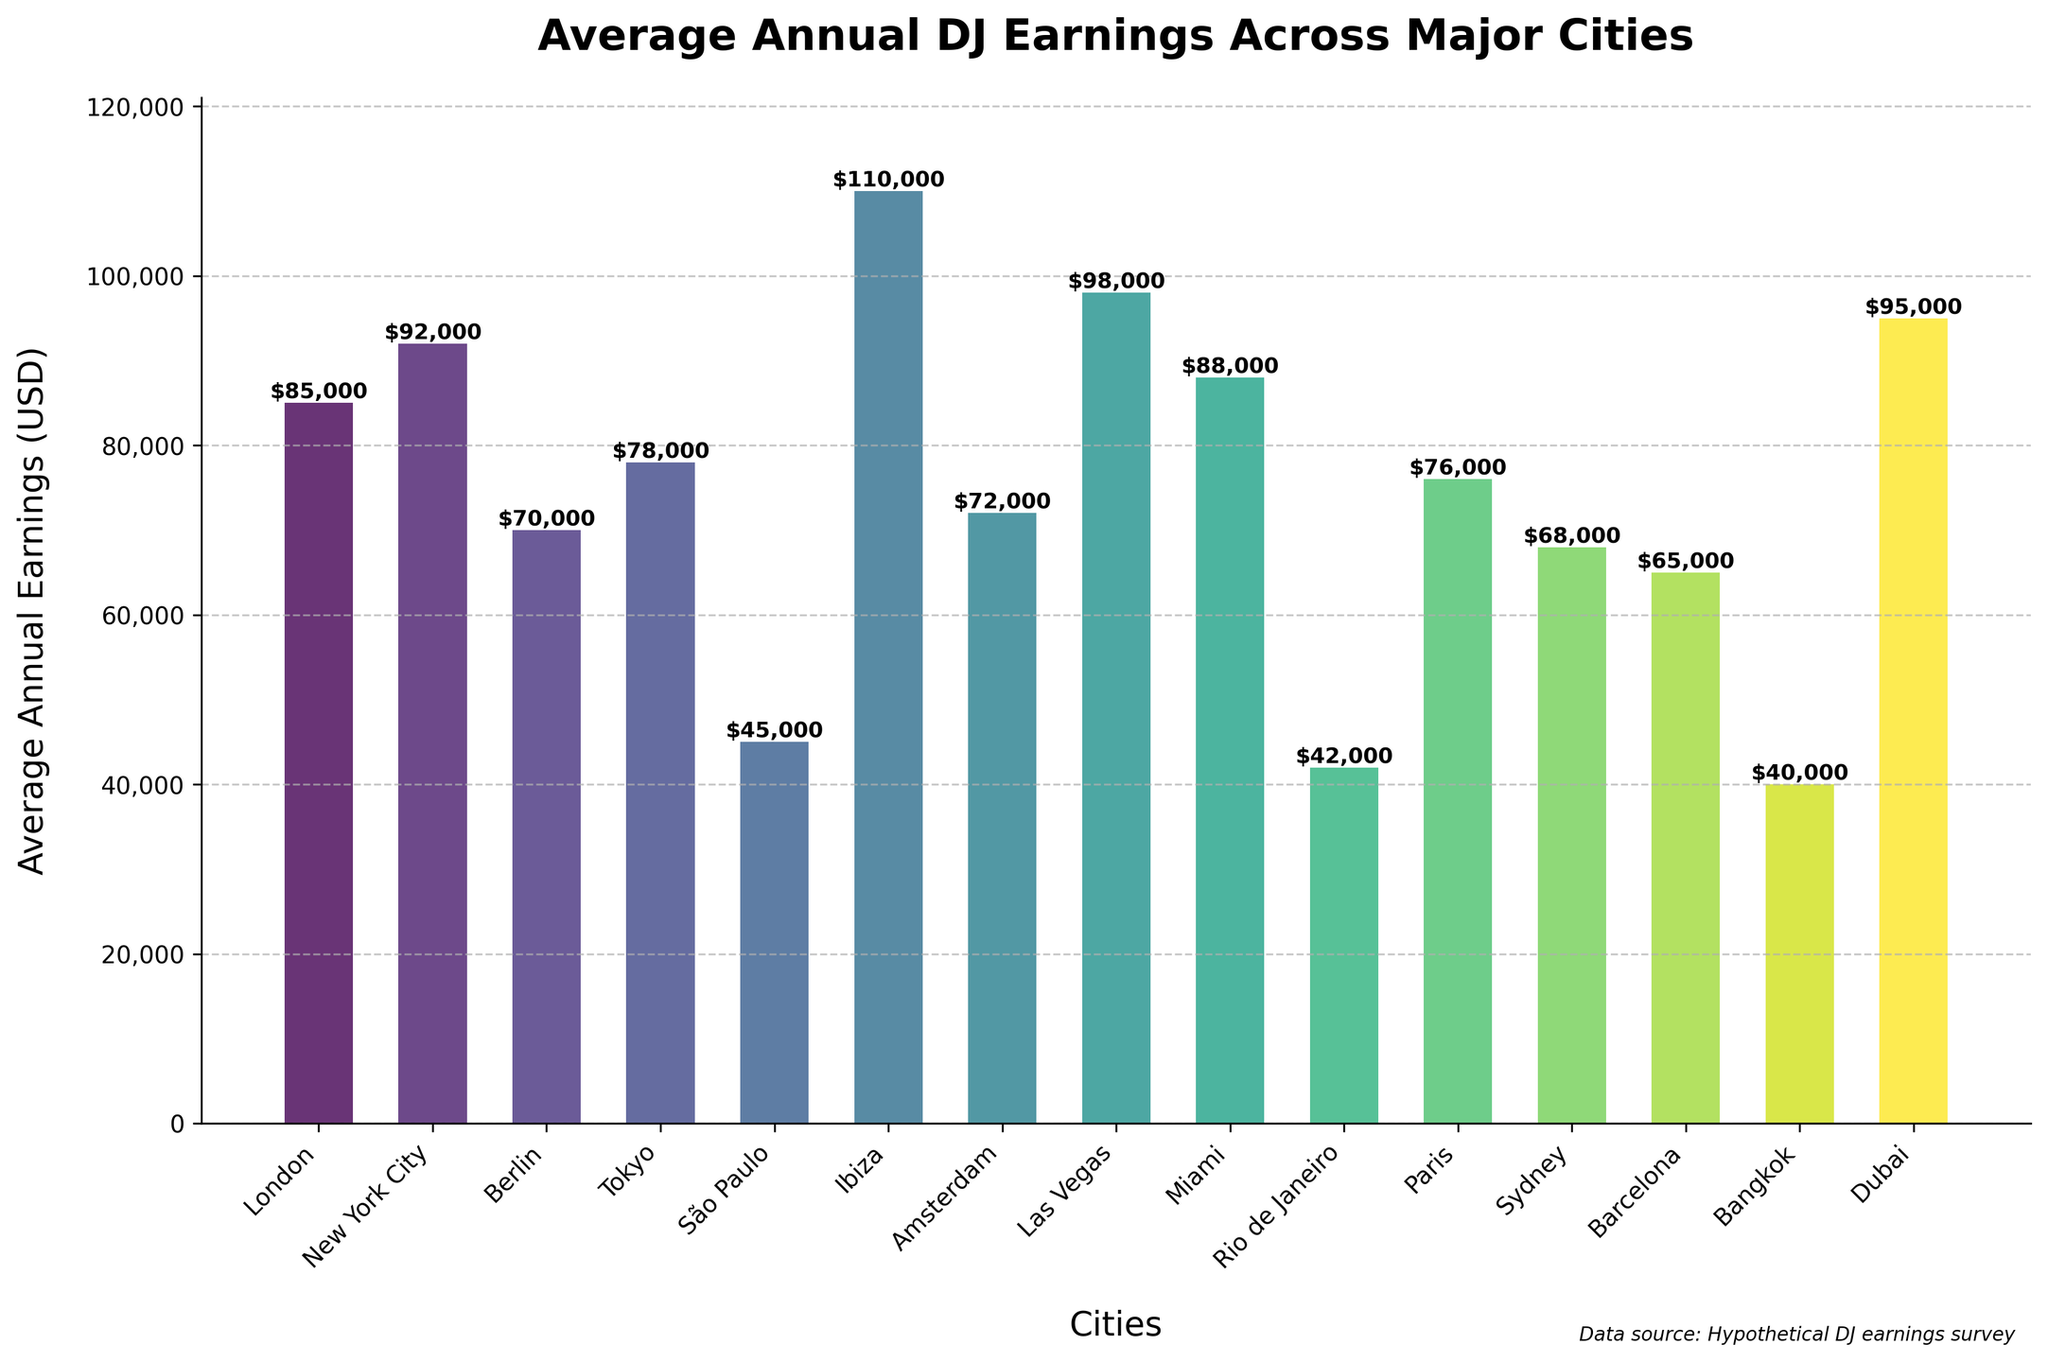Which city has the highest average annual DJ earnings? Look at the bar chart and identify the city with the tallest bar. The tallest bar represents the highest value.
Answer: Ibiza Which city has the lowest average annual DJ earnings? Look at the bar chart and identify the city with the shortest bar. The shortest bar represents the lowest value.
Answer: Bangkok How much higher are the average annual DJ earnings in Ibiza compared to São Paulo? Find the height of the bars for Ibiza and São Paulo. Subtract the value of São Paulo from the value of Ibiza. Calculation: 110,000 - 45,000.
Answer: 65,000 What’s the average annual DJ earnings of the top three earning cities? Identify and add up the earnings of the top three cities (Ibiza, Las Vegas, and New York City) and then divide by 3. Calculation: (110,000 + 98,000 + 92,000) / 3.
Answer: 100,000 Which city earns more, Berlin or Paris, and by how much? Compare the heights of the bars for Berlin and Paris. Subtract the smaller value from the larger value. Calculation: 76,000 - 70,000.
Answer: Paris by 6,000 What is the difference in average annual DJ earnings between the highest and lowest earning cities? Subtract the value of the lowest earning city (Bangkok) from the highest earning city (Ibiza). Calculation: 110,000 - 40,000.
Answer: 70,000 How many cities have average annual DJ earnings above 80,000 USD? Count the number of bars that extend above the 80,000 mark on the y-axis.
Answer: 5 What is the combined average annual DJ earnings of Tokyo and Amsterdam? Add the values represented by the heights of the bars for Tokyo and Amsterdam. Calculation: 78,000 + 72,000.
Answer: 150,000 Which cities have average annual DJ earnings closest to 70,000 USD? Identify the bars that are near the 70,000 mark on the y-axis.
Answer: Berlin, Amsterdam, and Paris What is the difference in earnings between New York City and Dubai? Subtract the value for Dubai from the value for New York City. Calculation: 92,000 - 95,000.
Answer: -3,000 